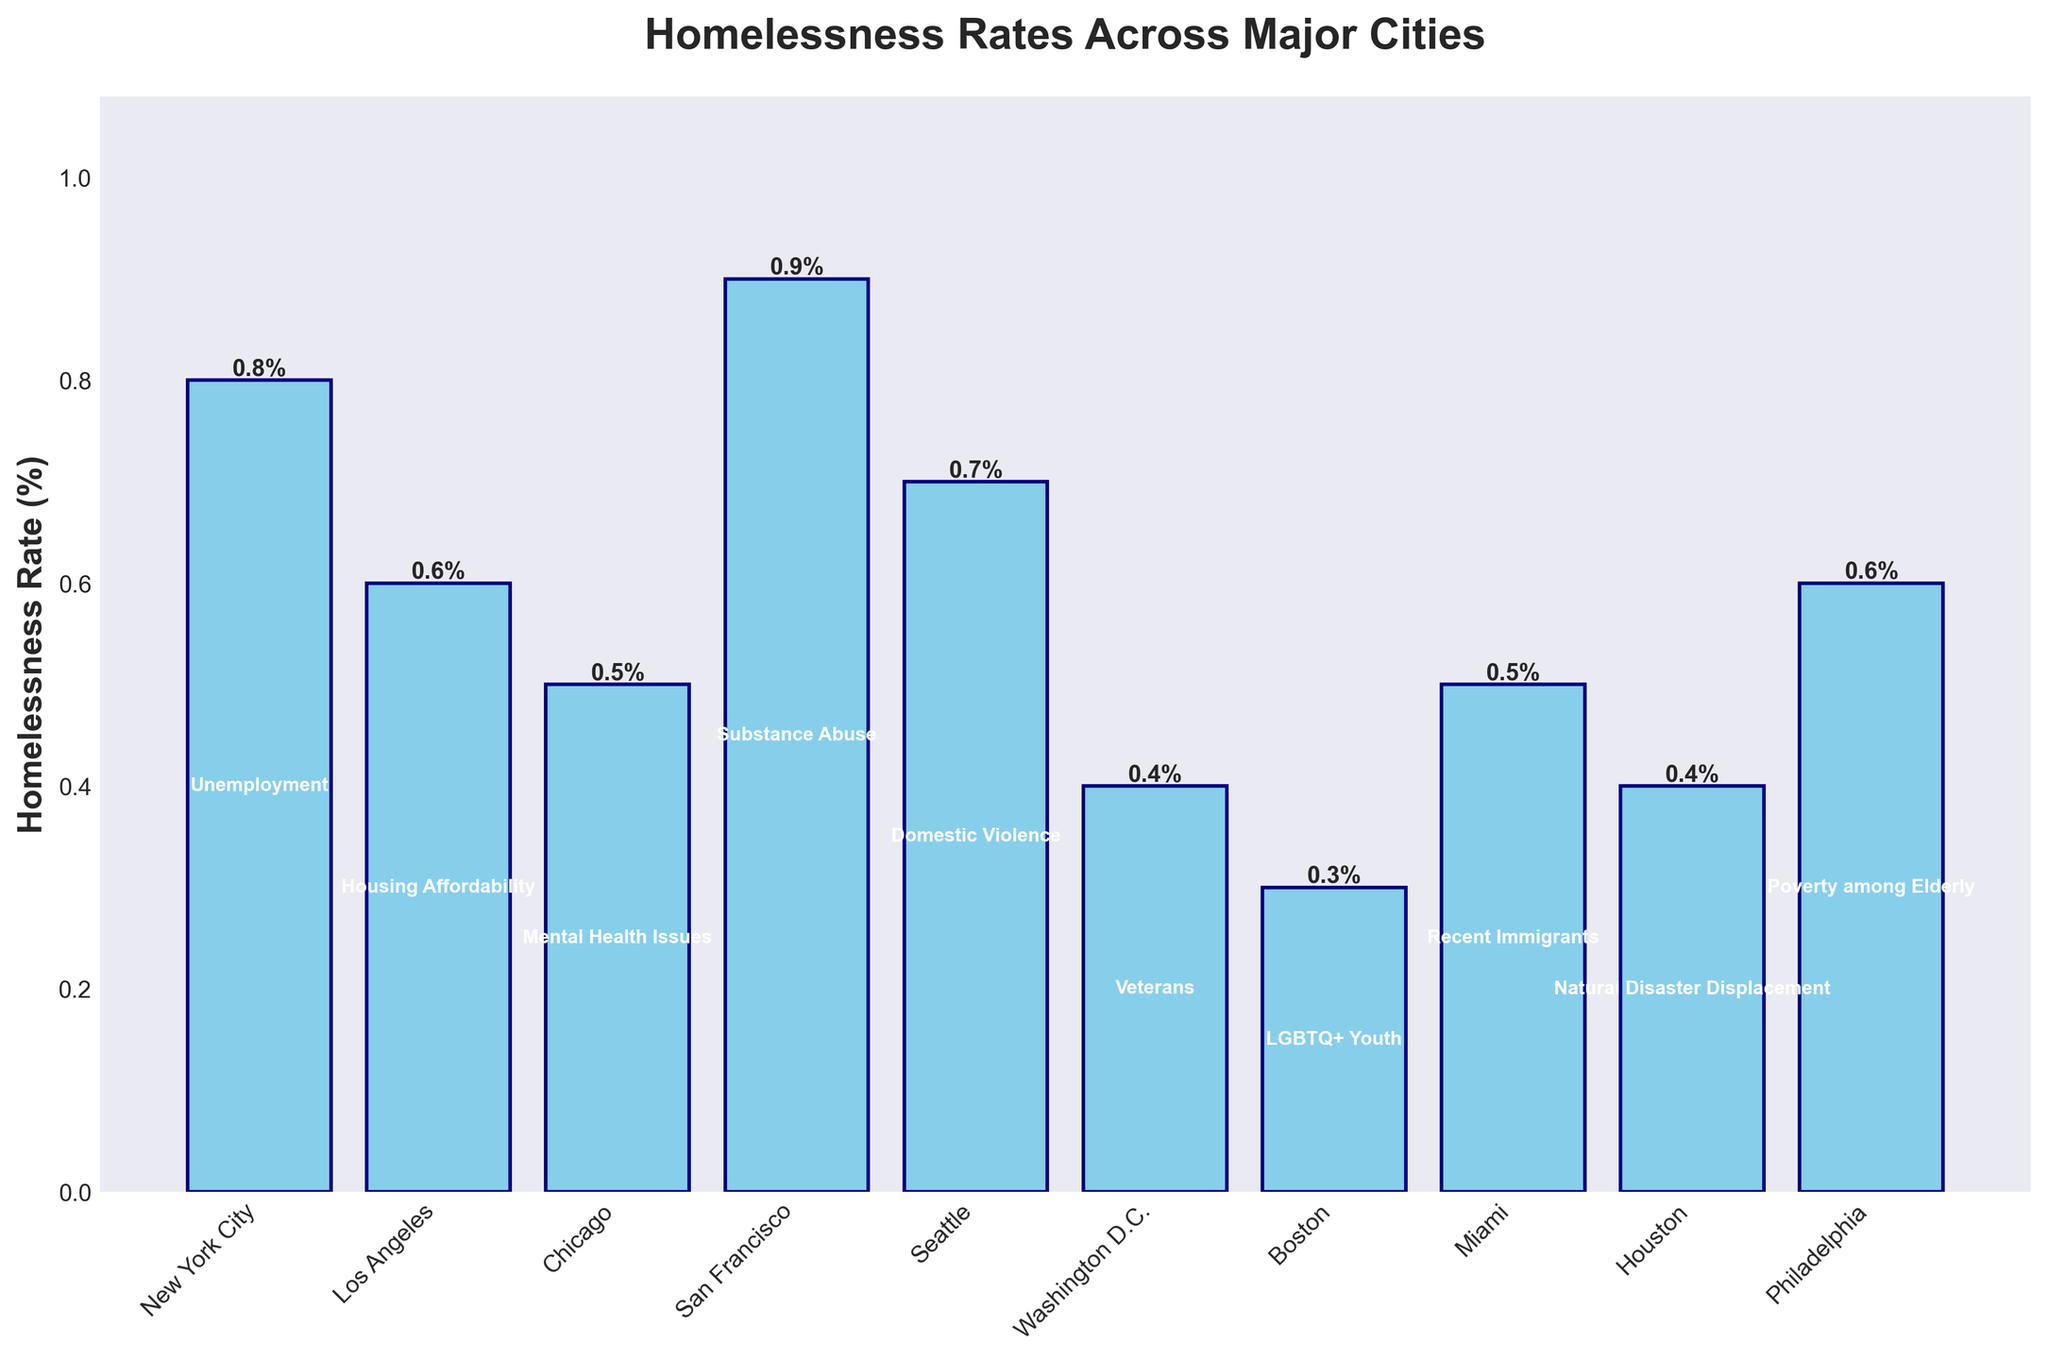What's the city with the highest homelessness rate? First identify the tallest bar representing the highest homelessness rate from the chart. The tallest bar belongs to San Francisco.
Answer: San Francisco Which city has a homelessness rate of 0.3%? Look for the bar corresponding to a 0.3% homelessness rate, which is the shortest bar. The label at the bottom indicates it is Boston.
Answer: Boston Which primary demographic factor is associated with New York City's homelessness rate? Locate the bar labeled 'New York City' and observe the text in the middle of the bar which indicates the primary demographic factor. It shows 'Unemployment'.
Answer: Unemployment Compare the homelessness rates of Chicago and Miami. Which one is higher? Find the bars for 'Chicago' and 'Miami' and compare their heights. Both bars indicate the same level, 0.5%.
Answer: Same rate Which city has a higher homelessness rate: Seattle or Los Angeles? Locate the bars for 'Seattle' and 'Los Angeles' and compare their heights. The 'Seattle' bar is higher than the 'Los Angeles' bar.
Answer: Seattle What is the average homelessness rate among the cities listed? Sum all the homelessness rates and divide by the number of cities. \((0.8 + 0.6 + 0.5 + 0.9 + 0.7 + 0.4 + 0.3 + 0.5 + 0.4 + 0.6) / 10 = 5.7/10 = 0.57\).
Answer: 0.57% Which two cities have equal homelessness rates, and what is the rate? Identify bars with the same height and check the corresponding labels. 'Chicago' and 'Miami' both have a homelessness rate of 0.5%.
Answer: Chicago and Miami, 0.5% What primary demographic factor is common among the cities with the two lowest homelessness rates? Identify the two cities with the shortest bars (Boston and Washington D.C.) and their primary demographic factors. The factors are 'LGBTQ+ Youth' for Boston and 'Veterans' for Washington D.C. No common factor.
Answer: None What is the combined homelessness rate of Boston, Houston, and Washington D.C.? Sum the homelessness rates of Boston (0.3%), Houston (0.4%), and Washington D.C. (0.4%). \(0.3 + 0.4 + 0.4 = 1.1%\).
Answer: 1.1% How much higher is San Francisco's homelessness rate compared to Boston's? Subtract Boston's homelessness rate from San Francisco's. \(0.9% - 0.3% = 0.6%\).
Answer: 0.6% List the cities in ascending order of their homelessness rates. Order the homelessness rates from smallest to largest and list the corresponding cities: Boston (0.3%), Washington D.C. (0.4%), Houston (0.4%), Chicago (0.5%), Miami (0.5%), Los Angeles (0.6%), Philadelphia (0.6%), Seattle (0.7%), New York City (0.8%), San Francisco (0.9%).
Answer: Boston, Washington D.C., Houston, Chicago, Miami, Los Angeles, Philadelphia, Seattle, New York City, San Francisco 